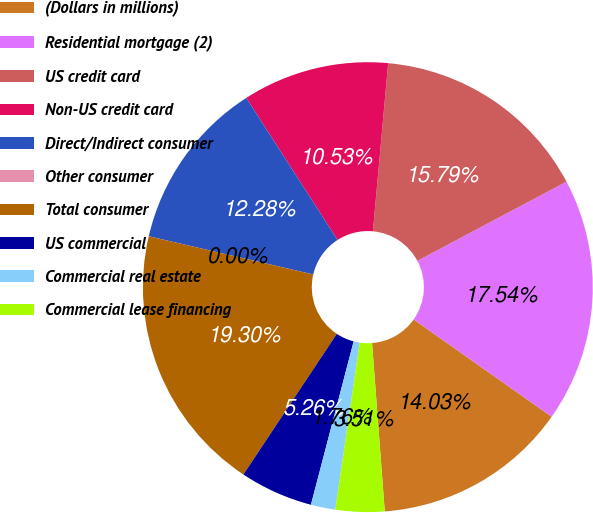<chart> <loc_0><loc_0><loc_500><loc_500><pie_chart><fcel>(Dollars in millions)<fcel>Residential mortgage (2)<fcel>US credit card<fcel>Non-US credit card<fcel>Direct/Indirect consumer<fcel>Other consumer<fcel>Total consumer<fcel>US commercial<fcel>Commercial real estate<fcel>Commercial lease financing<nl><fcel>14.03%<fcel>17.54%<fcel>15.79%<fcel>10.53%<fcel>12.28%<fcel>0.0%<fcel>19.3%<fcel>5.26%<fcel>1.76%<fcel>3.51%<nl></chart> 